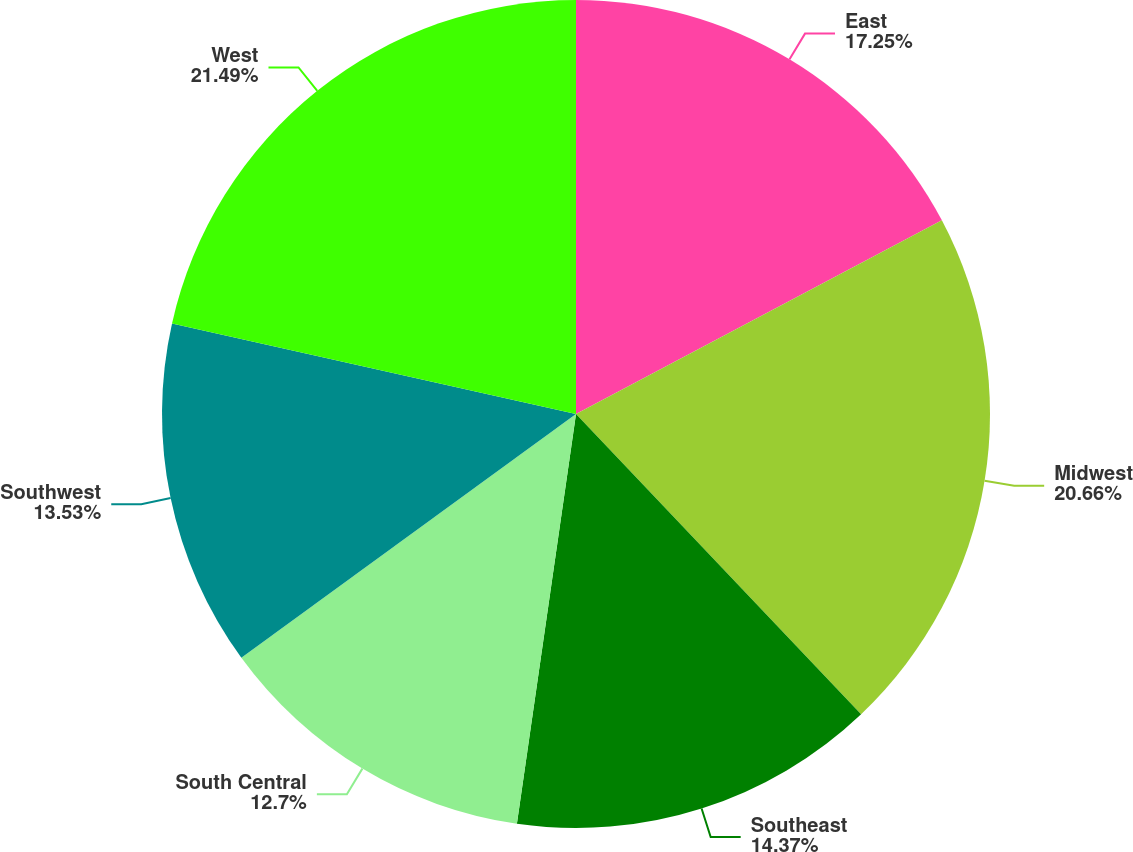Convert chart. <chart><loc_0><loc_0><loc_500><loc_500><pie_chart><fcel>East<fcel>Midwest<fcel>Southeast<fcel>South Central<fcel>Southwest<fcel>West<nl><fcel>17.25%<fcel>20.66%<fcel>14.37%<fcel>12.7%<fcel>13.53%<fcel>21.49%<nl></chart> 